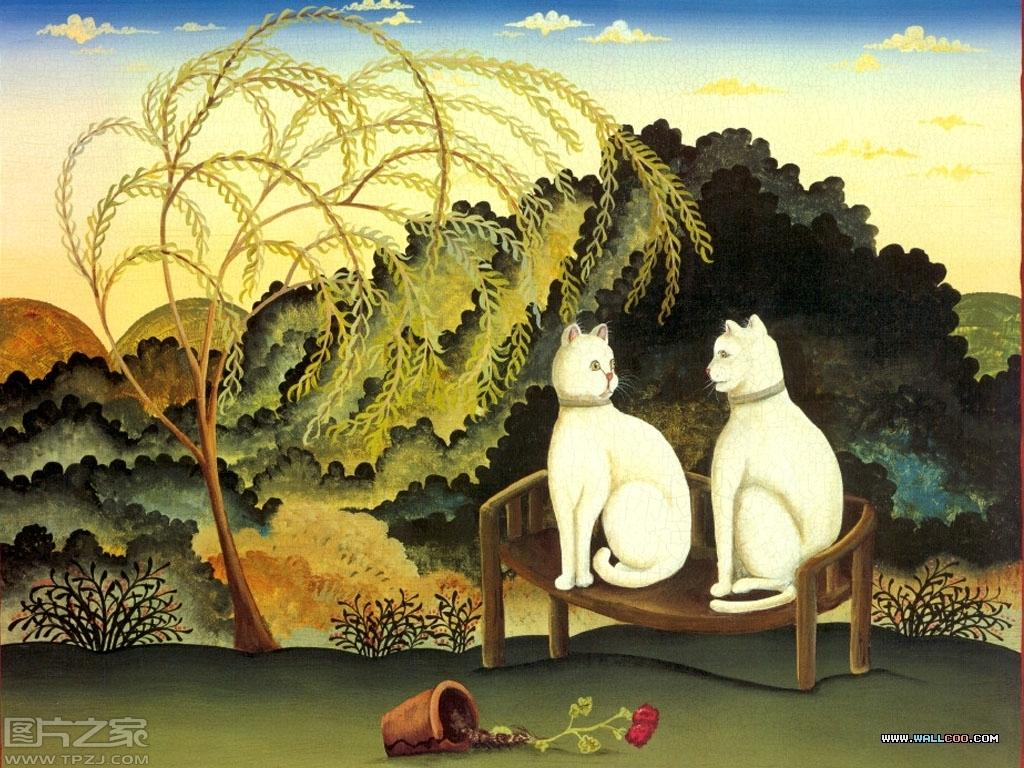What type of visual content is the image? The image is a poster. What animals are featured on the poster? There are two cats sitting on a bench. What is located on the ground in the image? There is a house plant on the ground. What can be seen in the background of the poster? There are trees, plants, and clouds in the sky in the background of the image. What letter is the cat holding in its tail in the image? There is no cat holding a letter in its tail in the image, as cats do not have the ability to hold objects with their tails. 